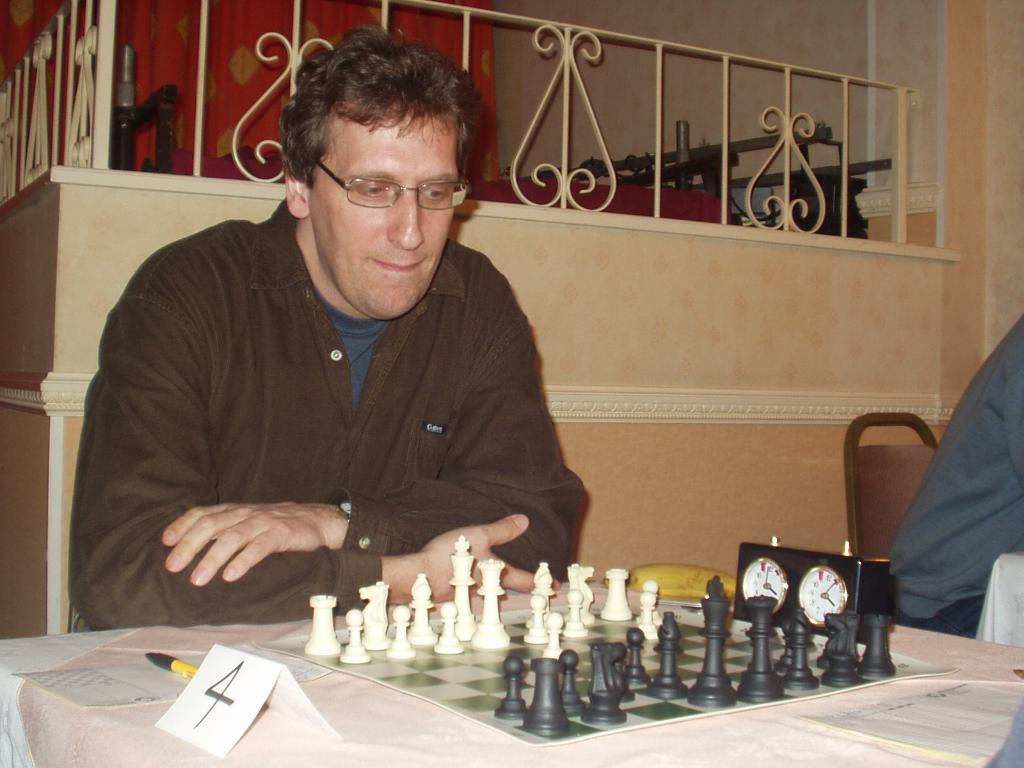What activity is the man engaged in? The man is playing chess. Can you describe any additional objects related to the game? There is a paper with the number 4 written on it, which may indicate a move or round. Is there any device to measure time during the game? Yes, there is a timer present. What can be seen in the background of the image? There is a fence at the back. What type of insect is crawling on the chessboard in the image? There are no insects present on the chessboard in the image. 